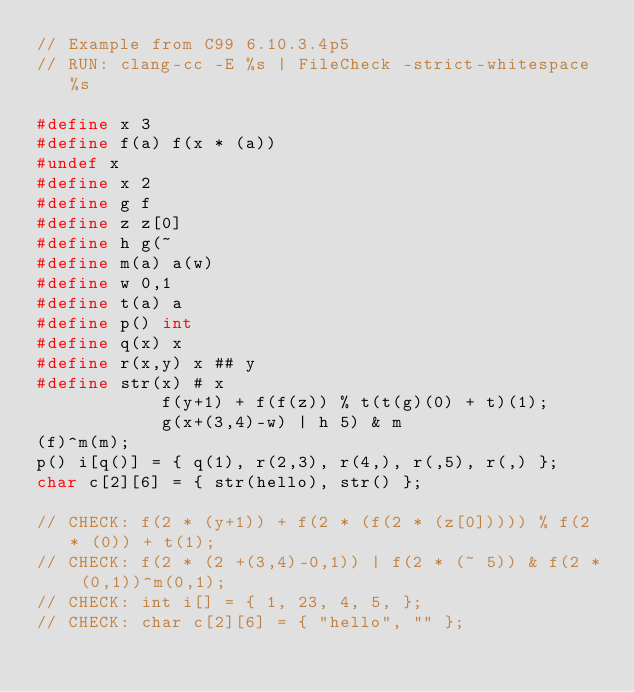Convert code to text. <code><loc_0><loc_0><loc_500><loc_500><_C_>// Example from C99 6.10.3.4p5
// RUN: clang-cc -E %s | FileCheck -strict-whitespace %s

#define x 3 
#define f(a) f(x * (a)) 
#undef x 
#define x 2 
#define g f 
#define z z[0] 
#define h g(~ 
#define m(a) a(w) 
#define w 0,1 
#define t(a) a 
#define p() int 
#define q(x) x 
#define r(x,y) x ## y 
#define str(x) # x 
            f(y+1) + f(f(z)) % t(t(g)(0) + t)(1); 
            g(x+(3,4)-w) | h 5) & m 
(f)^m(m); 
p() i[q()] = { q(1), r(2,3), r(4,), r(,5), r(,) }; 
char c[2][6] = { str(hello), str() }; 

// CHECK: f(2 * (y+1)) + f(2 * (f(2 * (z[0])))) % f(2 * (0)) + t(1);
// CHECK: f(2 * (2 +(3,4)-0,1)) | f(2 * (~ 5)) & f(2 * (0,1))^m(0,1);
// CHECK: int i[] = { 1, 23, 4, 5, };
// CHECK: char c[2][6] = { "hello", "" };

</code> 